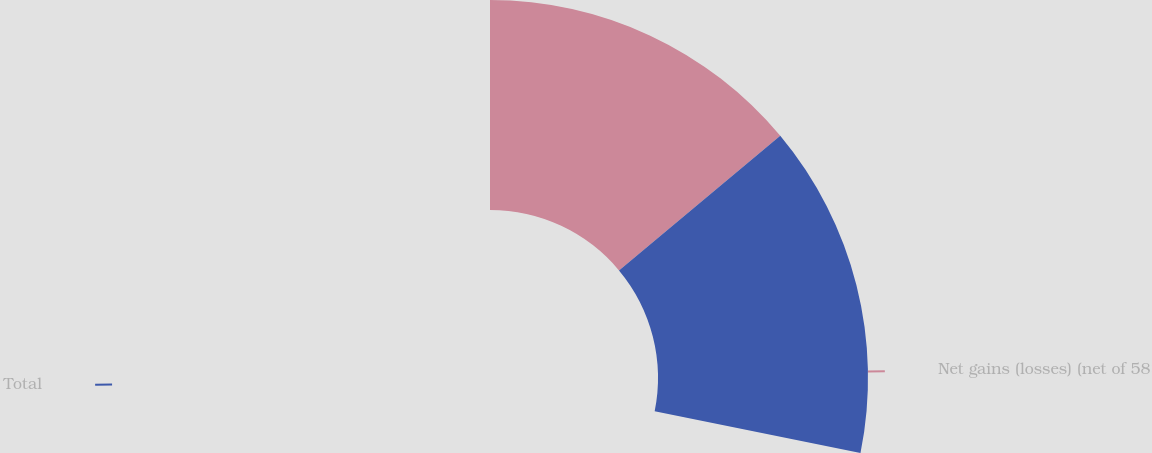<chart> <loc_0><loc_0><loc_500><loc_500><pie_chart><fcel>Net gains (losses) (net of 58<fcel>Total<nl><fcel>49.45%<fcel>50.55%<nl></chart> 